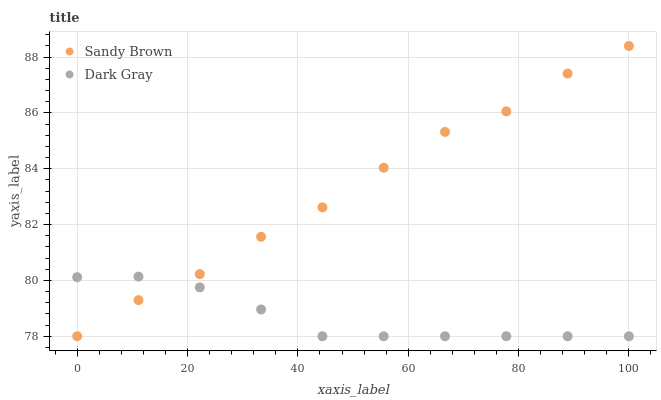Does Dark Gray have the minimum area under the curve?
Answer yes or no. Yes. Does Sandy Brown have the maximum area under the curve?
Answer yes or no. Yes. Does Sandy Brown have the minimum area under the curve?
Answer yes or no. No. Is Dark Gray the smoothest?
Answer yes or no. Yes. Is Sandy Brown the roughest?
Answer yes or no. Yes. Is Sandy Brown the smoothest?
Answer yes or no. No. Does Dark Gray have the lowest value?
Answer yes or no. Yes. Does Sandy Brown have the highest value?
Answer yes or no. Yes. Does Sandy Brown intersect Dark Gray?
Answer yes or no. Yes. Is Sandy Brown less than Dark Gray?
Answer yes or no. No. Is Sandy Brown greater than Dark Gray?
Answer yes or no. No. 